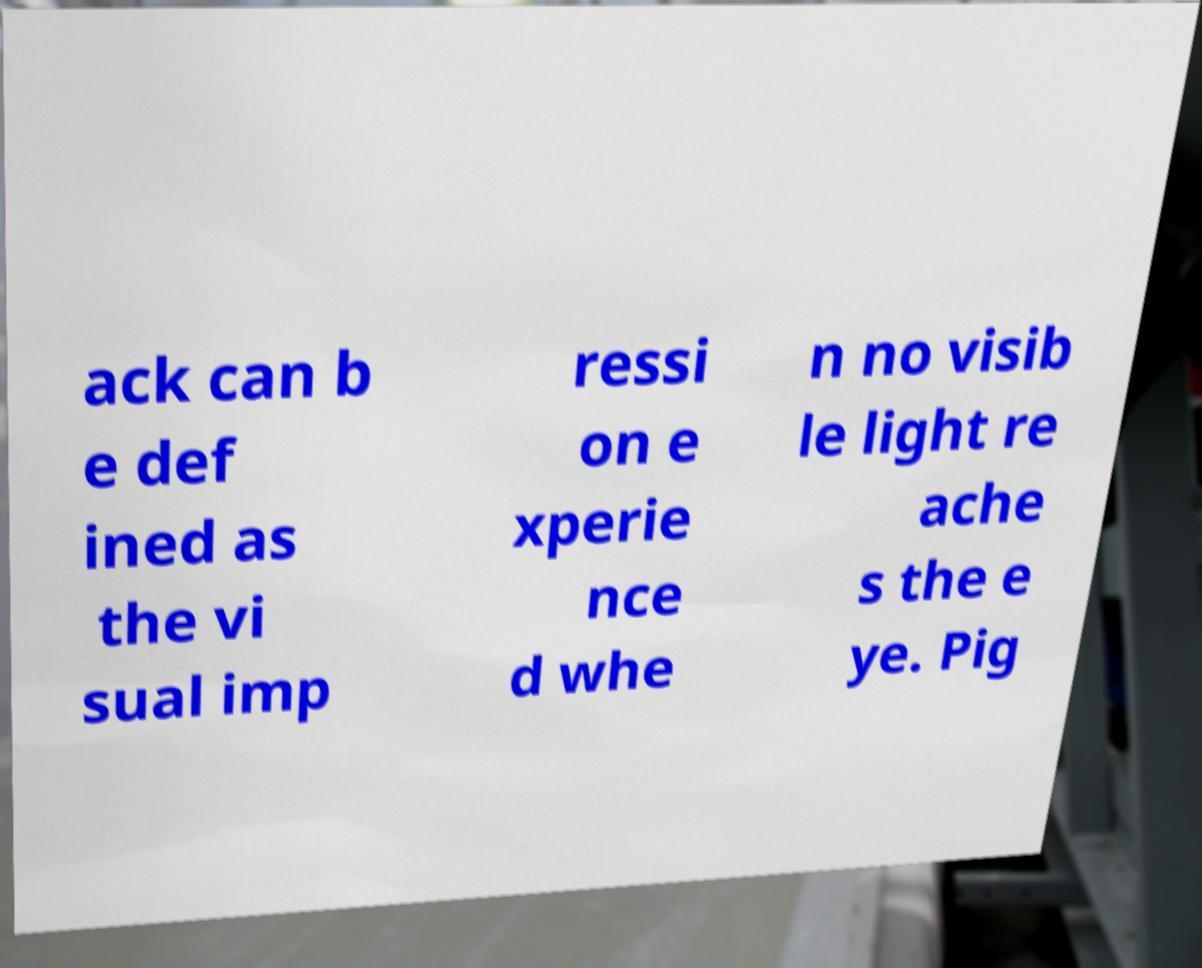I need the written content from this picture converted into text. Can you do that? ack can b e def ined as the vi sual imp ressi on e xperie nce d whe n no visib le light re ache s the e ye. Pig 